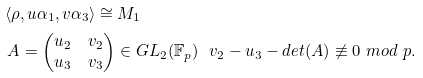<formula> <loc_0><loc_0><loc_500><loc_500>& \left \langle \rho , u \alpha _ { 1 } , v \alpha _ { 3 } \right \rangle \cong M _ { 1 } \\ & \ A = \begin{pmatrix} u _ { 2 } & v _ { 2 } \\ u _ { 3 } & v _ { 3 } \end{pmatrix} \in G L _ { 2 } ( \mathbb { F } _ { p } ) \ \ v _ { 2 } - u _ { 3 } - d e t ( A ) \not \equiv 0 \ m o d \ p .</formula> 